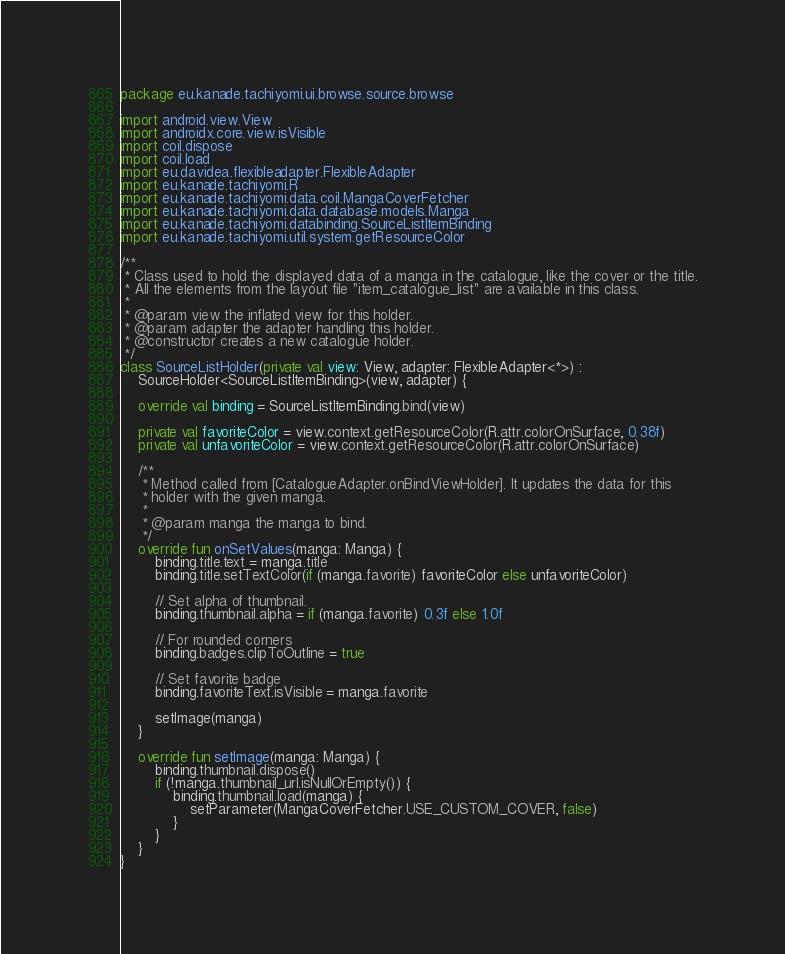<code> <loc_0><loc_0><loc_500><loc_500><_Kotlin_>package eu.kanade.tachiyomi.ui.browse.source.browse

import android.view.View
import androidx.core.view.isVisible
import coil.dispose
import coil.load
import eu.davidea.flexibleadapter.FlexibleAdapter
import eu.kanade.tachiyomi.R
import eu.kanade.tachiyomi.data.coil.MangaCoverFetcher
import eu.kanade.tachiyomi.data.database.models.Manga
import eu.kanade.tachiyomi.databinding.SourceListItemBinding
import eu.kanade.tachiyomi.util.system.getResourceColor

/**
 * Class used to hold the displayed data of a manga in the catalogue, like the cover or the title.
 * All the elements from the layout file "item_catalogue_list" are available in this class.
 *
 * @param view the inflated view for this holder.
 * @param adapter the adapter handling this holder.
 * @constructor creates a new catalogue holder.
 */
class SourceListHolder(private val view: View, adapter: FlexibleAdapter<*>) :
    SourceHolder<SourceListItemBinding>(view, adapter) {

    override val binding = SourceListItemBinding.bind(view)

    private val favoriteColor = view.context.getResourceColor(R.attr.colorOnSurface, 0.38f)
    private val unfavoriteColor = view.context.getResourceColor(R.attr.colorOnSurface)

    /**
     * Method called from [CatalogueAdapter.onBindViewHolder]. It updates the data for this
     * holder with the given manga.
     *
     * @param manga the manga to bind.
     */
    override fun onSetValues(manga: Manga) {
        binding.title.text = manga.title
        binding.title.setTextColor(if (manga.favorite) favoriteColor else unfavoriteColor)

        // Set alpha of thumbnail.
        binding.thumbnail.alpha = if (manga.favorite) 0.3f else 1.0f

        // For rounded corners
        binding.badges.clipToOutline = true

        // Set favorite badge
        binding.favoriteText.isVisible = manga.favorite

        setImage(manga)
    }

    override fun setImage(manga: Manga) {
        binding.thumbnail.dispose()
        if (!manga.thumbnail_url.isNullOrEmpty()) {
            binding.thumbnail.load(manga) {
                setParameter(MangaCoverFetcher.USE_CUSTOM_COVER, false)
            }
        }
    }
}
</code> 